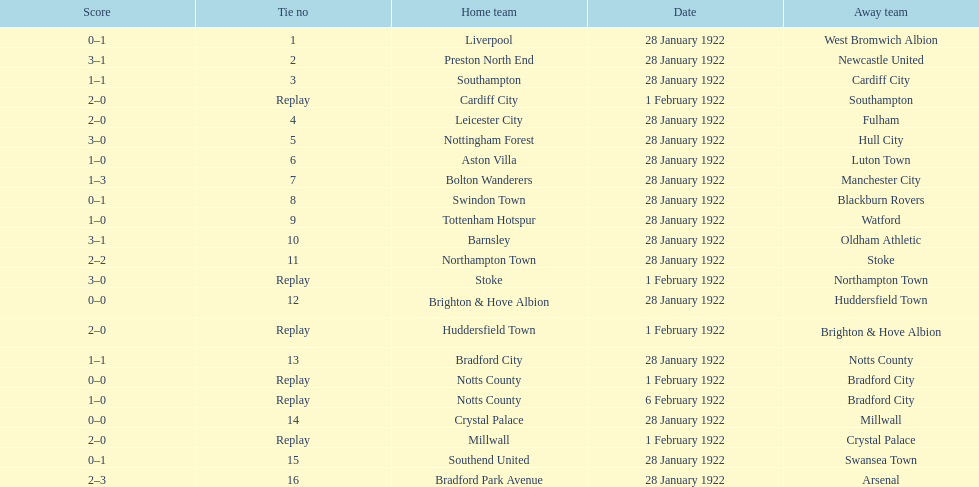How many total points were scored in the second round proper? 45. 